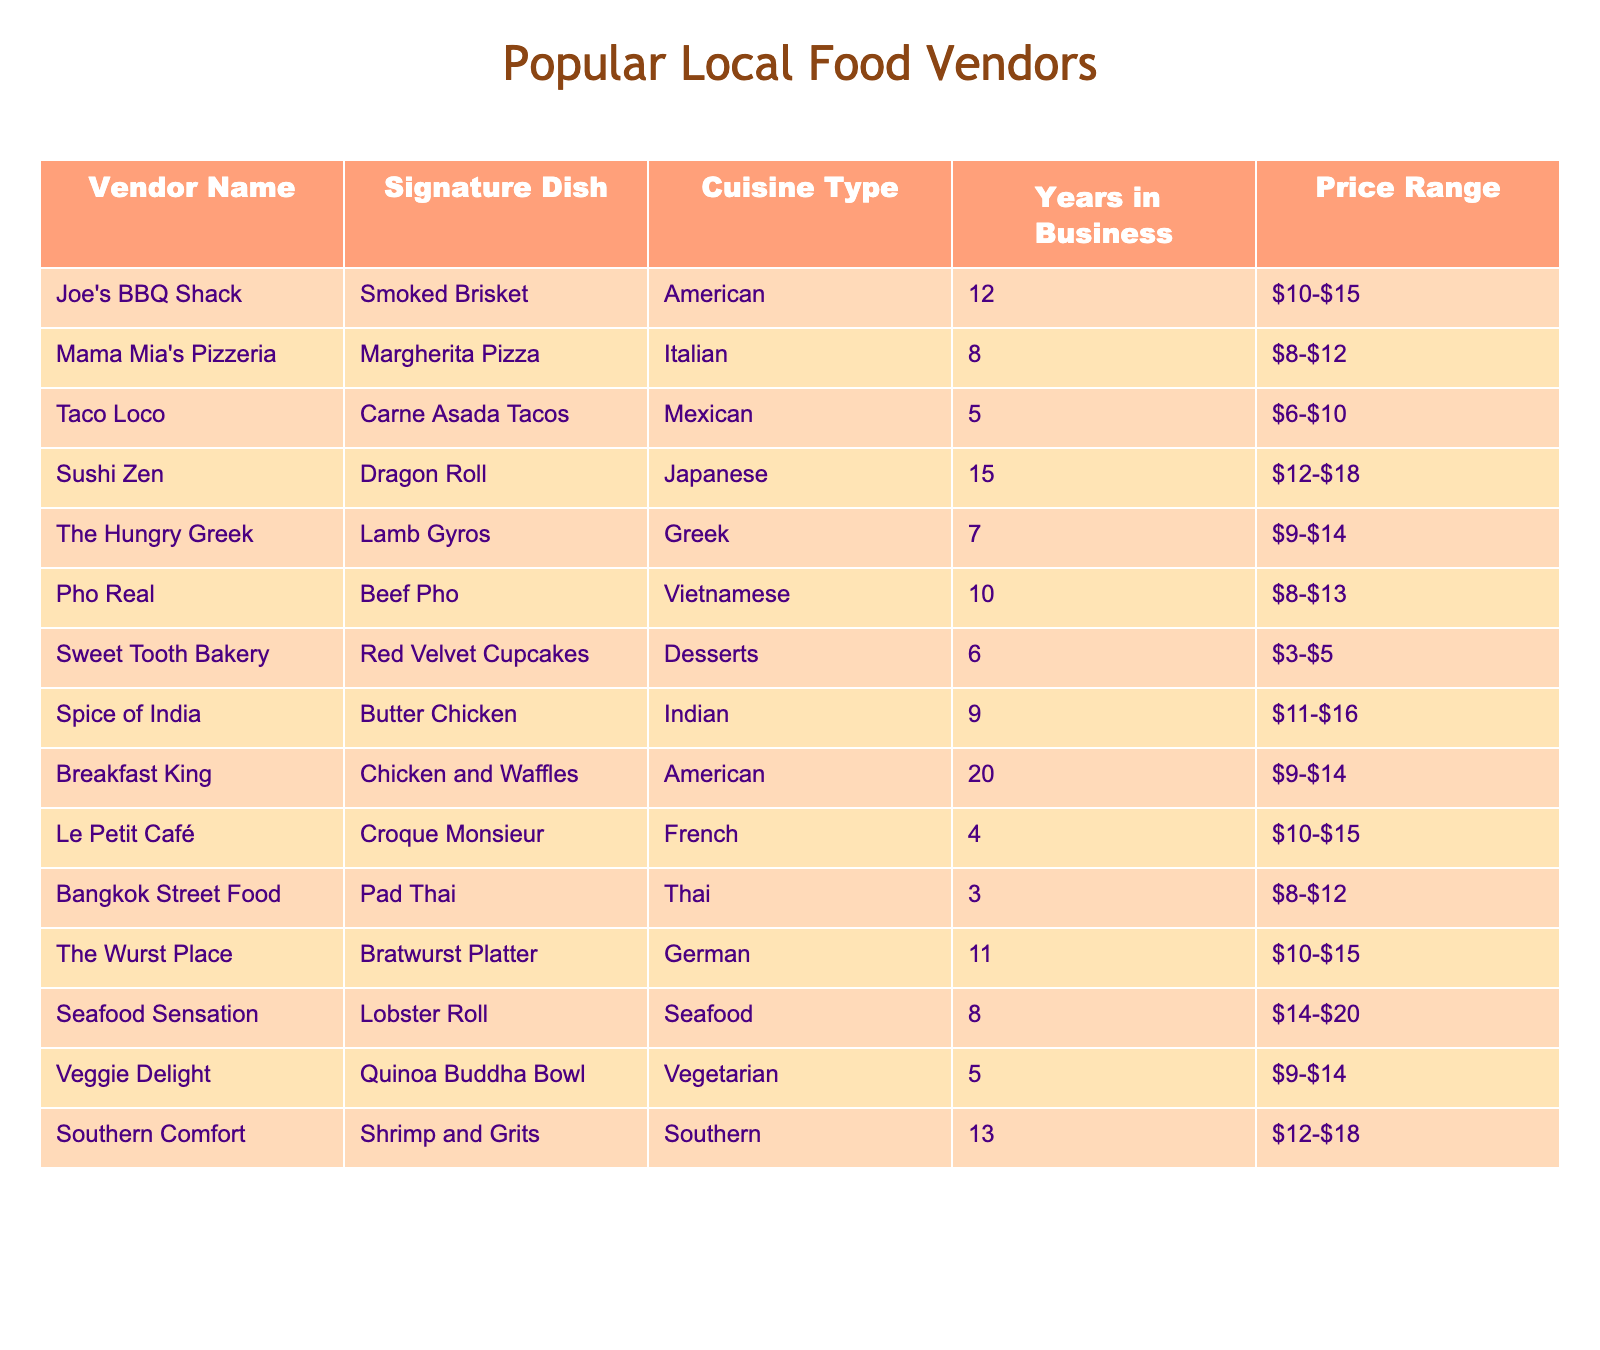What is the signature dish of Mama Mia's Pizzeria? According to the table, Mama Mia's Pizzeria offers Margherita Pizza as its signature dish.
Answer: Margherita Pizza Which vendor has been in business the longest? The vendor with the most years in business is Breakfast King, which has been operating for 20 years.
Answer: Breakfast King How many vendors offer dishes in the price range of $10 to $15? The table shows that there are 6 vendors with dishes priced between $10 and $15: Joe's BBQ Shack, The Hungry Greek, The Wurst Place, Breakfast King, Le Petit Café, and Seafood Sensation.
Answer: 6 Is Pho Real's signature dish a dessert? It is noted in the table that Pho Real's signature dish is Beef Pho, which is not a dessert. Therefore, the answer is no.
Answer: No Which cuisine type has the most vendors? By counting the cuisine types listed, we find that American has 3 vendors (Joe's BBQ Shack, Breakfast King, and The Hungry Greek), which is more than any other cuisine type.
Answer: American What is the average price range of the vendors offering vegetarian dishes? Only one vendor, Veggie Delight, offers a vegetarian dish priced between $9-$14. Thus, the average price range is simply $9-$14.
Answer: $9-$14 Which vendor offers a seafood dish? The table specifies that Seafood Sensation offers the Lobster Roll, a seafood dish.
Answer: Seafood Sensation If you combine the years in business for Taco Loco and Spice of India, what is the total? Taco Loco has been in business for 5 years and Spice of India for 9 years. Adding these gives 5 + 9 = 14 years.
Answer: 14 Are there more dessert vendors than Italian vendors? There is 1 dessert vendor (Sweet Tooth Bakery) and 1 Italian vendor (Mama Mia's Pizzeria), making them equal, so the answer is no.
Answer: No What is the total number of years in business for all vendors that have been open for less than 10 years? The vendors with less than 10 years in business are Taco Loco (5), Le Petit Café (4), Bangkok Street Food (3), and Veggie Delight (5). Summing these gives 5 + 4 + 3 + 5 = 17 years.
Answer: 17 